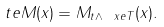Convert formula to latex. <formula><loc_0><loc_0><loc_500><loc_500>\ t e { M } ( x ) = M _ { t \wedge \ x e { T } } ( x ) .</formula> 